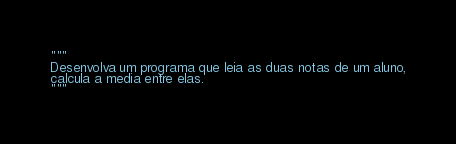Convert code to text. <code><loc_0><loc_0><loc_500><loc_500><_Python_>"""
Desenvolva um programa que leia as duas notas de um aluno,
calcula a media entre elas.
"""</code> 